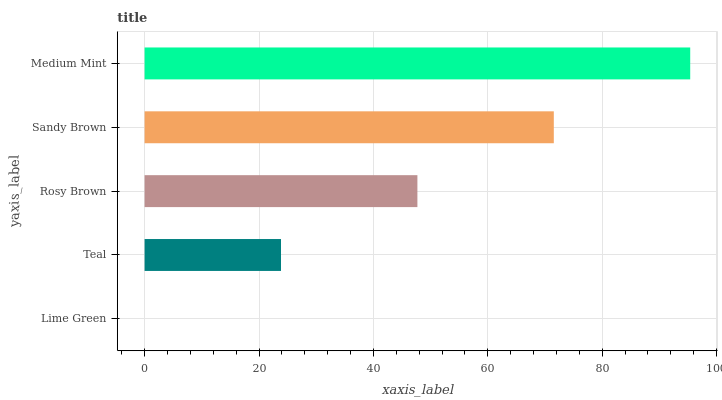Is Lime Green the minimum?
Answer yes or no. Yes. Is Medium Mint the maximum?
Answer yes or no. Yes. Is Teal the minimum?
Answer yes or no. No. Is Teal the maximum?
Answer yes or no. No. Is Teal greater than Lime Green?
Answer yes or no. Yes. Is Lime Green less than Teal?
Answer yes or no. Yes. Is Lime Green greater than Teal?
Answer yes or no. No. Is Teal less than Lime Green?
Answer yes or no. No. Is Rosy Brown the high median?
Answer yes or no. Yes. Is Rosy Brown the low median?
Answer yes or no. Yes. Is Teal the high median?
Answer yes or no. No. Is Sandy Brown the low median?
Answer yes or no. No. 